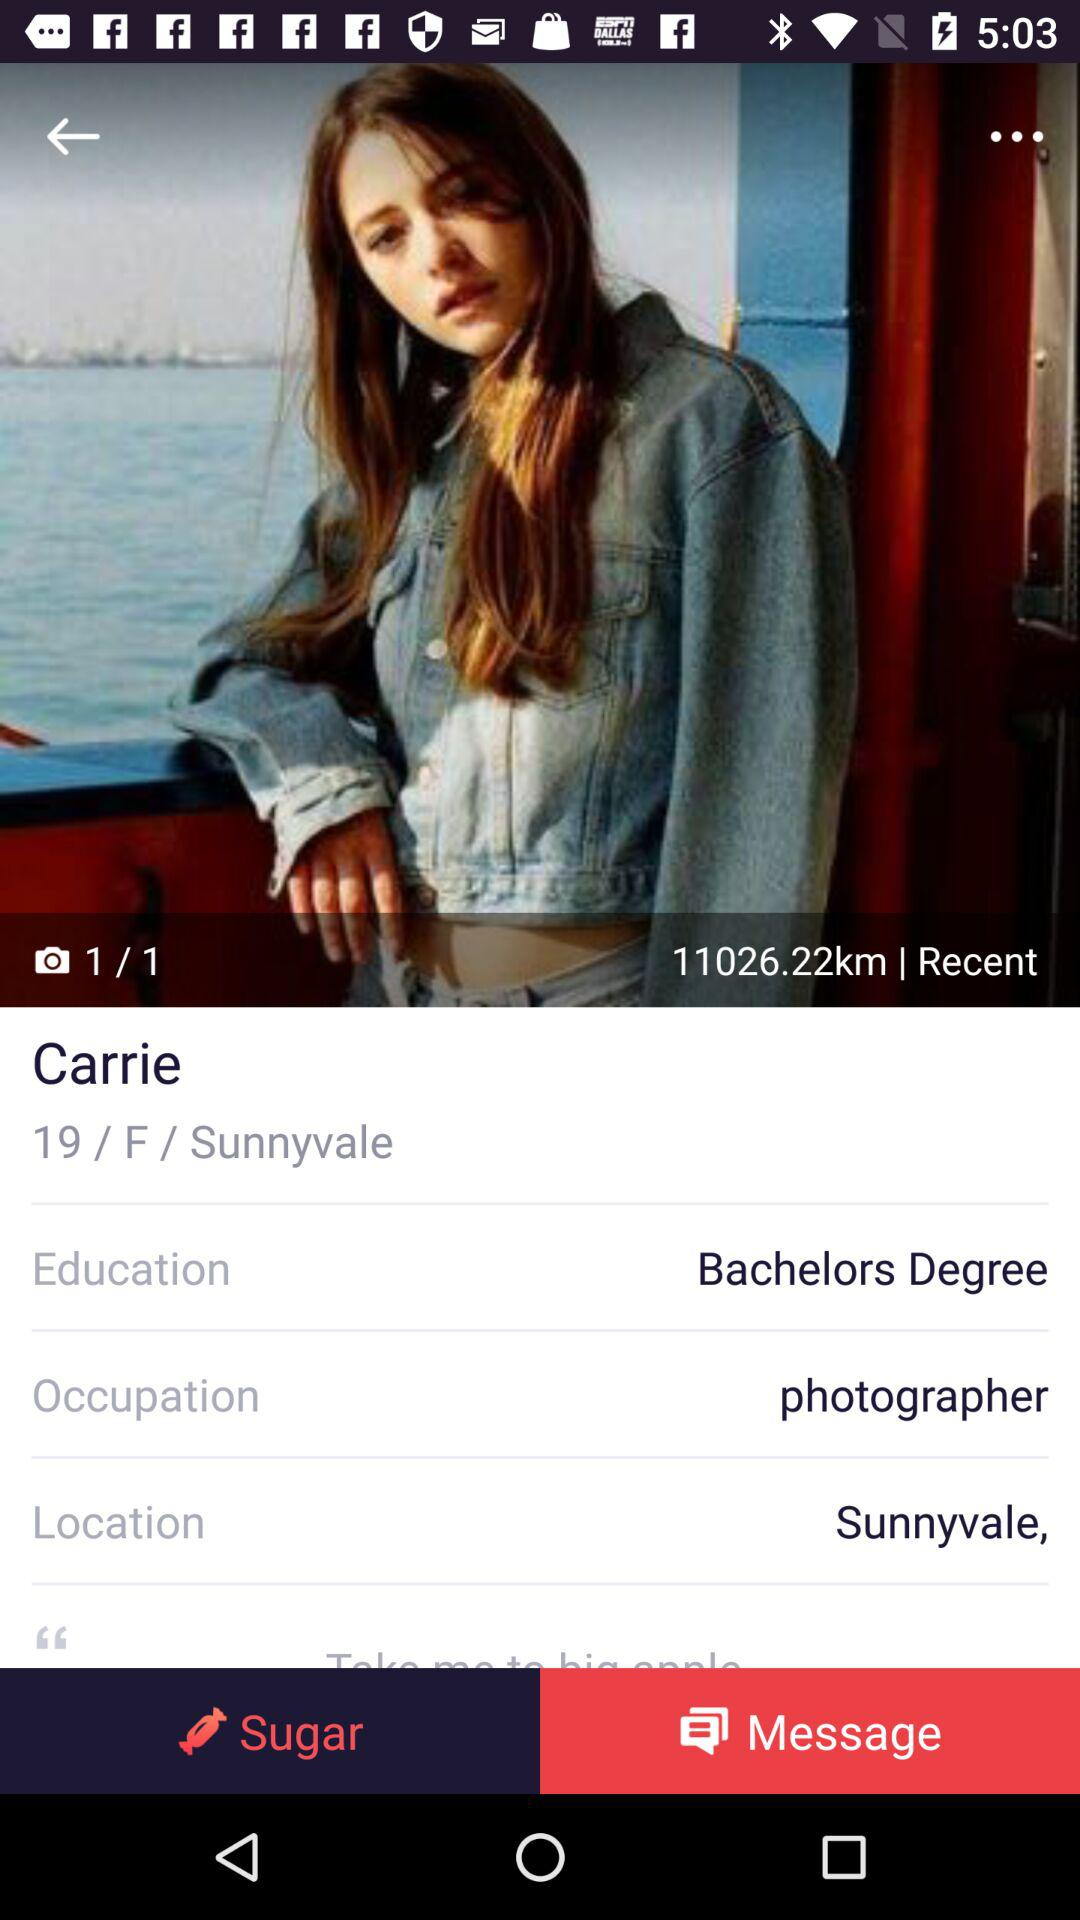What is the current location? The current location is Sunnyvale. 